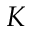Convert formula to latex. <formula><loc_0><loc_0><loc_500><loc_500>K</formula> 